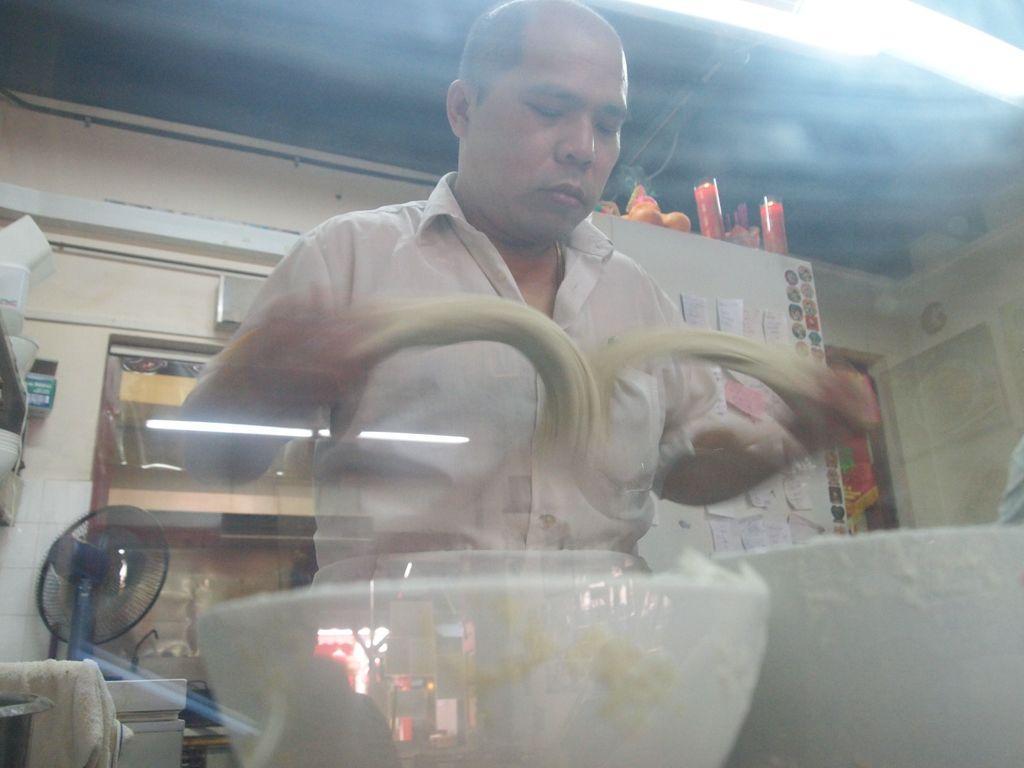Could you give a brief overview of what you see in this image? In this image, we can see a person holding some objects. We can see some bowls and a table fan. We can see the wall with some posters and objects. We can see some objects on the left. We can see some objects attached to the roof. 